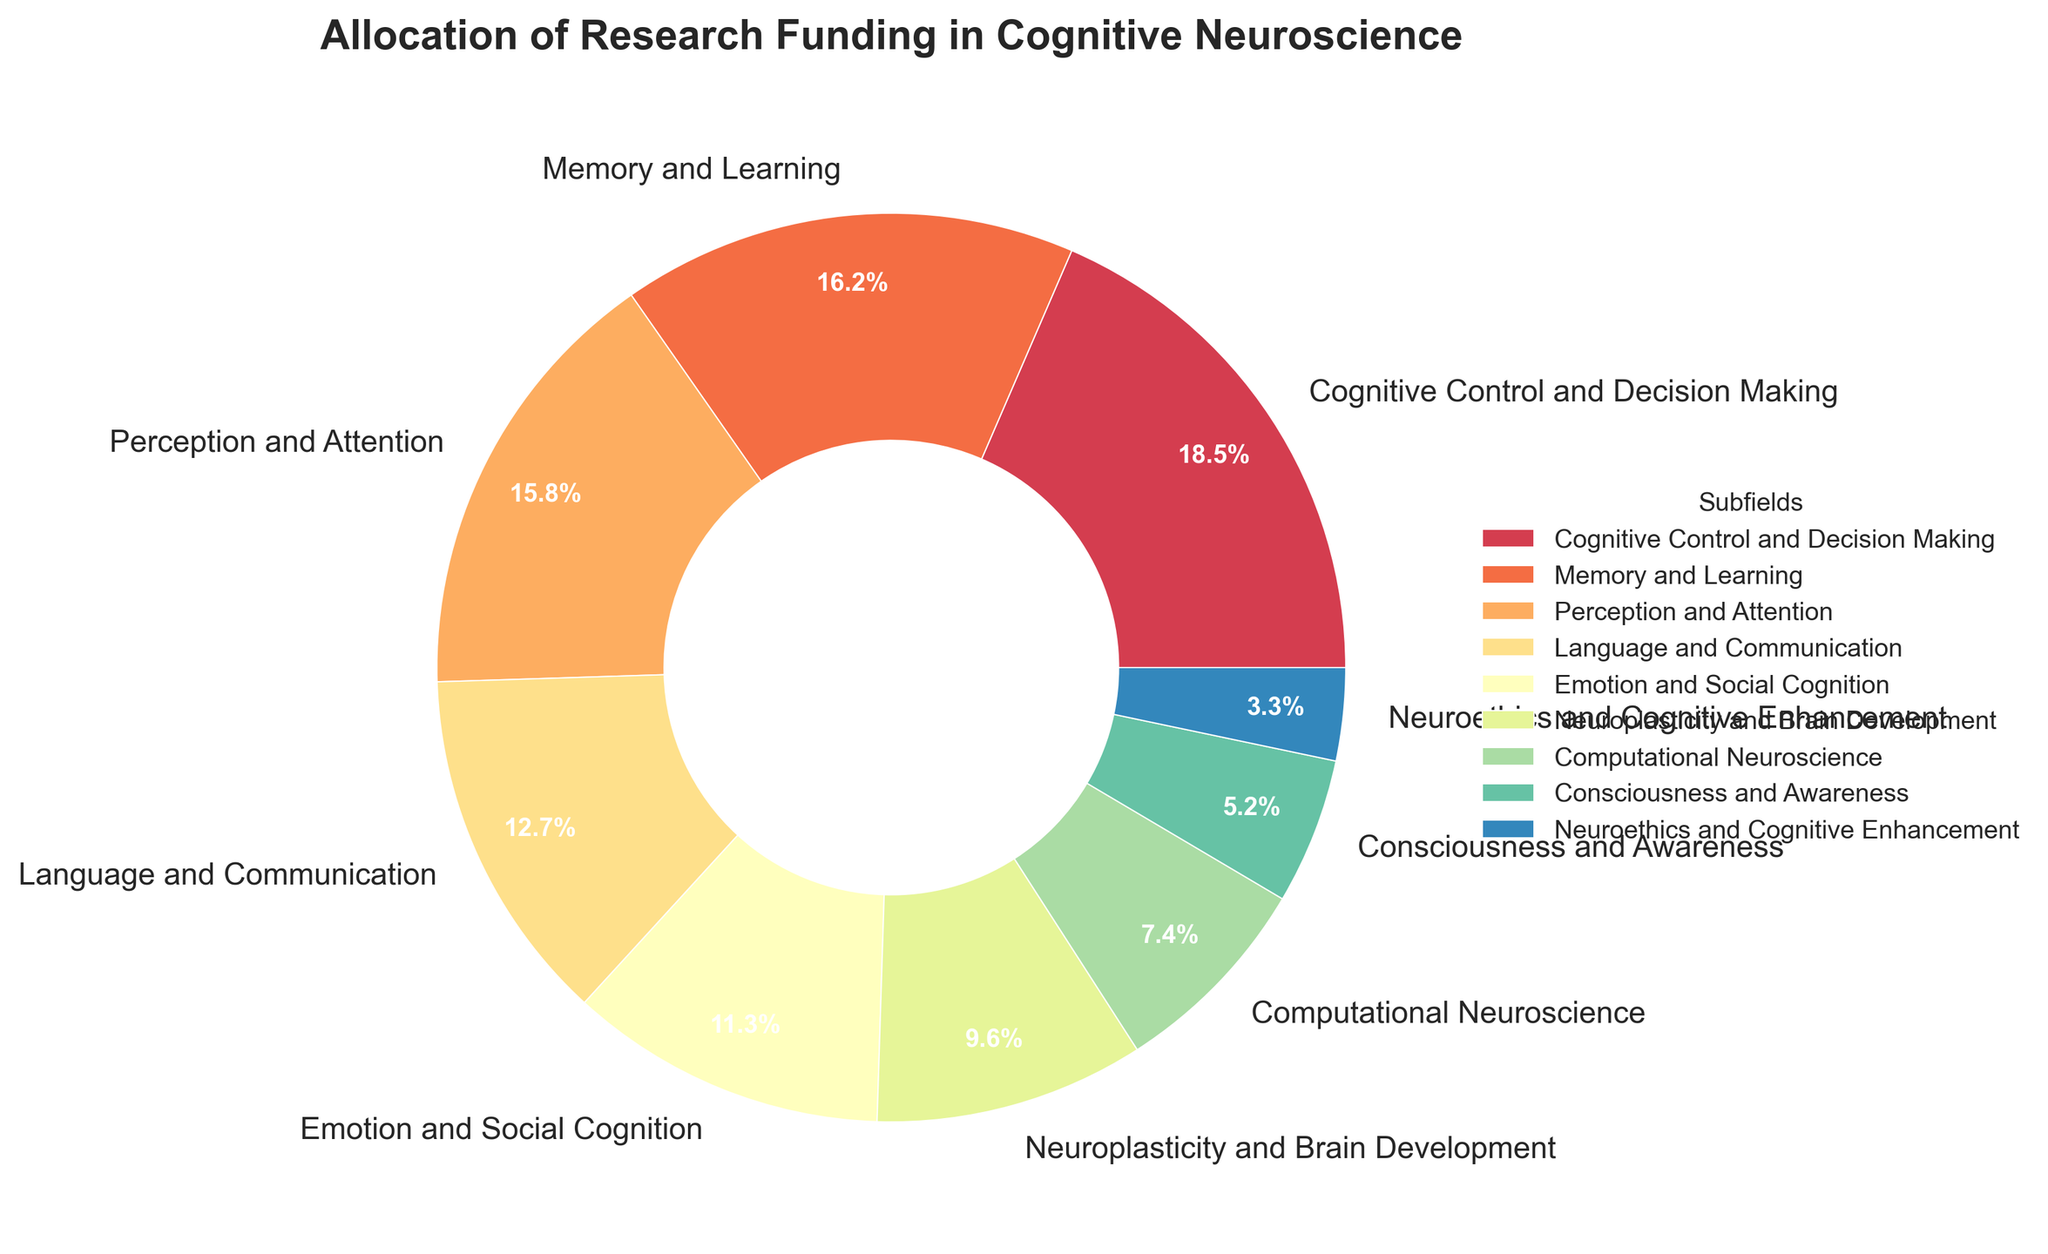What's the subfield with the highest research funding allocation? All subfields and their respective funding percentages are listed, and "Cognitive Control and Decision Making" has the highest value at 18.5%.
Answer: Cognitive Control and Decision Making Which subfield receives less funding: "Memory and Learning" or "Neuroplasticity and Brain Development"? "Memory and Learning" has a funding percentage of 16.2%, while "Neuroplasticity and Brain Development" has 9.6%. Since 9.6% is less than 16.2%, "Neuroplasticity and Brain Development" receives less funding.
Answer: Neuroplasticity and Brain Development What is the combined funding percentage for "Emotion and Social Cognition" and "Neuroplasticity and Brain Development"? The funding for "Emotion and Social Cognition" is 11.3% and for "Neuroplasticity and Brain Development" is 9.6%. Adding these together: 11.3% + 9.6% = 20.9%.
Answer: 20.9% How much more funding does "Perception and Attention" receive compared to "Language and Communication"? "Perception and Attention" receives 15.8%, and "Language and Communication" receives 12.7%. Subtracting the two: 15.8% - 12.7% = 3.1%.
Answer: 3.1% Which subfield has the smallest funding allocation, and what is its percentage? The smallest funding allocation percentage is for "Neuroethics and Cognitive Enhancement" at 3.3%.
Answer: Neuroethics and Cognitive Enhancement, 3.3% Are "Memory and Learning" and "Perception and Attention" funded almost equally, and what's the difference in their percentages? "Memory and Learning" receives 16.2%, and "Perception and Attention" receives 15.8%. Their difference is 16.2% - 15.8% = 0.4%. They are funded almost equally with a slight difference of 0.4%.
Answer: Yes, 0.4% If you combine the funding percentages of the two least funded subfields, what is their total? The two least funded subfields are "Neuroethics and Cognitive Enhancement" (3.3%) and "Consciousness and Awareness" (5.2%). Adding these: 3.3% + 5.2% = 8.5%.
Answer: 8.5% What part of the chart is represented by "Computational Neuroscience", and how can you identify it visually? "Computational Neuroscience" is represented by the segment that encompasses 7.4% of the pie chart. Visually, it can be identified by checking the legend and looking for the segment labeled as "Computational Neuroscience".
Answer: 7.4%, legend Which subfield has a funding percentage that is closest to 10% and what is the exact value? "Neuroplasticity and Brain Development" has a percentage closest to 10% with an exact value of 9.6%.
Answer: Neuroplasticity and Brain Development, 9.6% Compare the combined funding of "Cognitive Control and Decision Making" and "Language and Communication" to "Perception and Attention" and "Memory and Learning". Which combination receives more funding? "Cognitive Control and Decision Making" + "Language and Communication" = 18.5% + 12.7% = 31.2%. "Perception and Attention" + "Memory and Learning" = 15.8% + 16.2% = 32%. Comparing 31.2% and 32%, the latter combination receives more funding.
Answer: Perception and Attention and Memory and Learning 